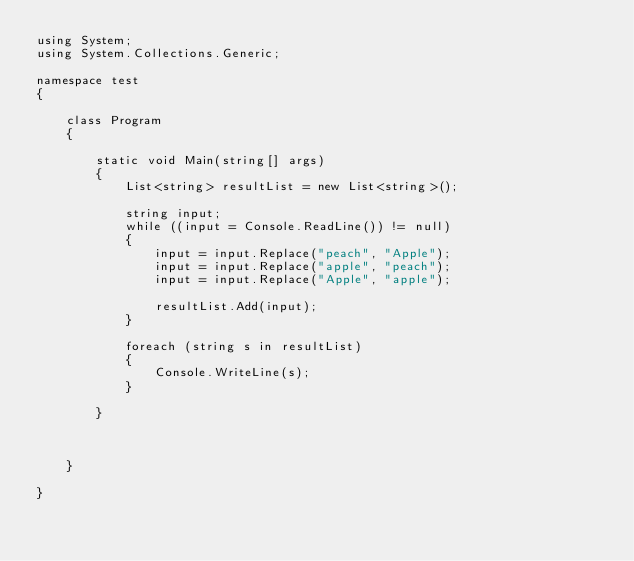<code> <loc_0><loc_0><loc_500><loc_500><_C#_>using System;
using System.Collections.Generic;

namespace test
{

    class Program
    {

        static void Main(string[] args)
        {
            List<string> resultList = new List<string>();

            string input;
            while ((input = Console.ReadLine()) != null)
            {
                input = input.Replace("peach", "Apple");
                input = input.Replace("apple", "peach");
                input = input.Replace("Apple", "apple");

                resultList.Add(input);
            }

            foreach (string s in resultList)
            {
                Console.WriteLine(s);
            }

        }



    }

}</code> 